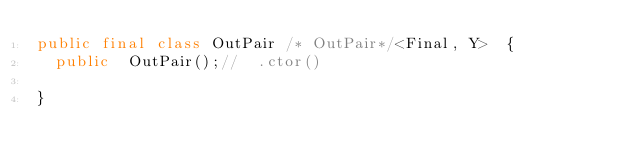Convert code to text. <code><loc_0><loc_0><loc_500><loc_500><_Java_>public final class OutPair /* OutPair*/<Final, Y>  {
  public  OutPair();//  .ctor()

}
</code> 